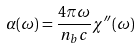Convert formula to latex. <formula><loc_0><loc_0><loc_500><loc_500>\alpha ( \omega ) = \frac { 4 \pi \omega } { n _ { b } c } \chi ^ { \prime \prime } ( \omega )</formula> 